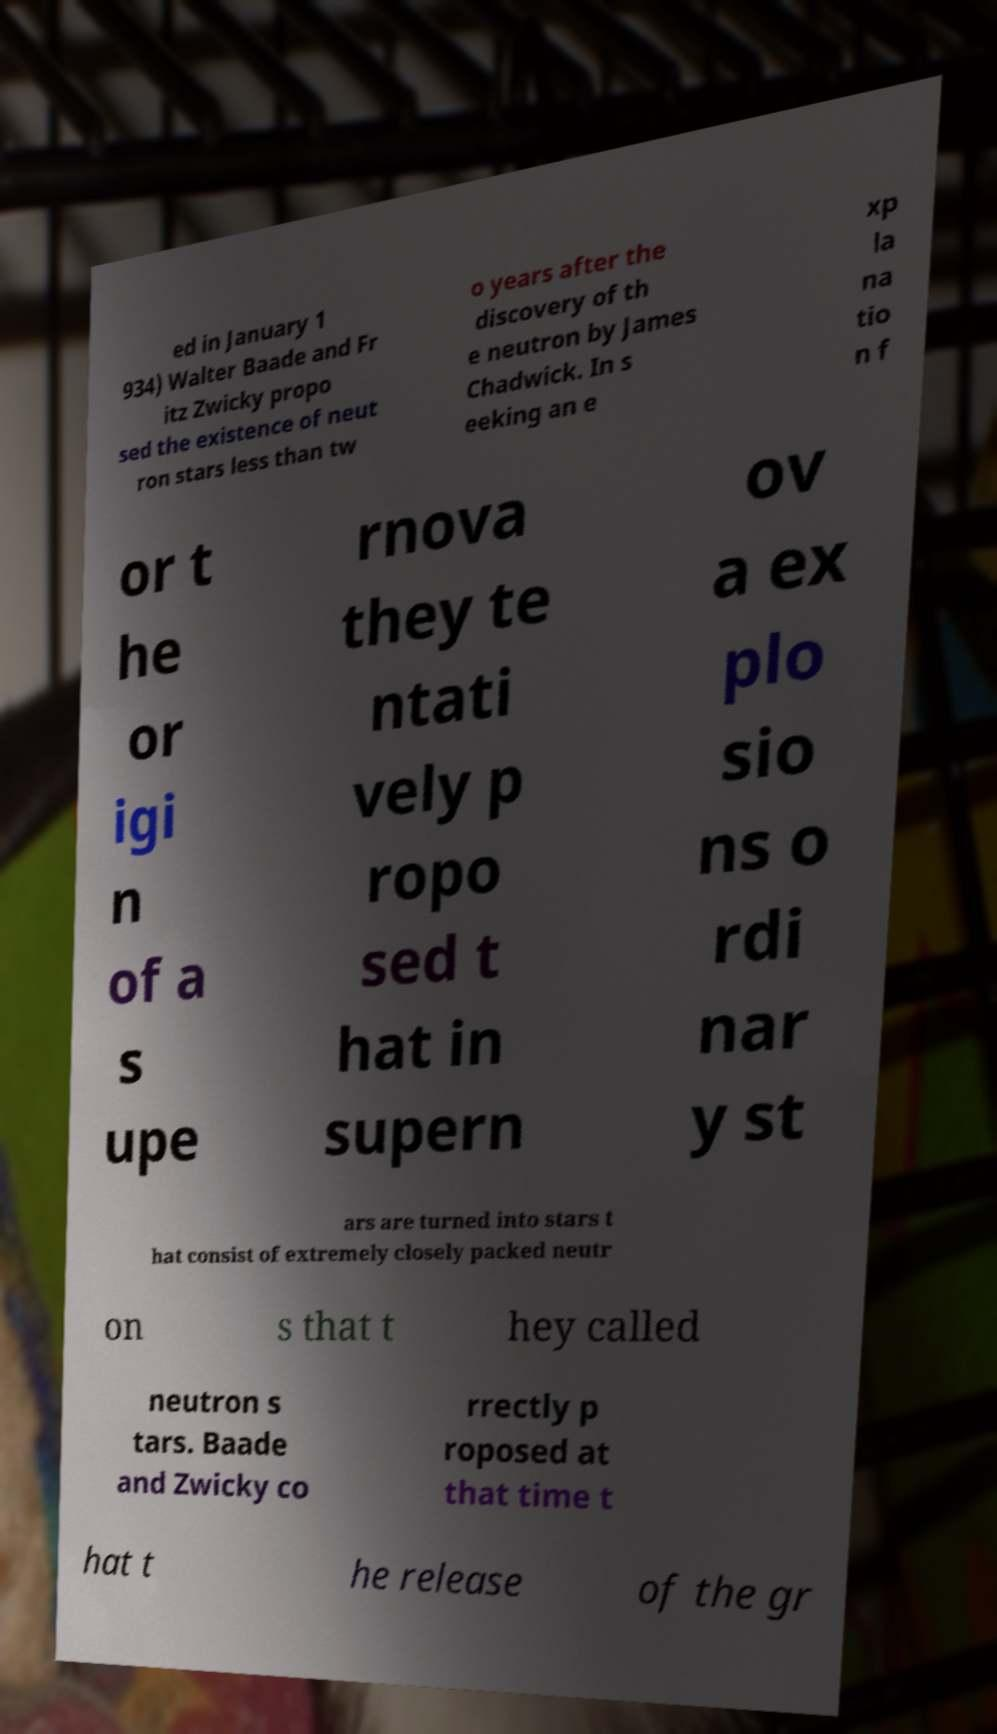There's text embedded in this image that I need extracted. Can you transcribe it verbatim? ed in January 1 934) Walter Baade and Fr itz Zwicky propo sed the existence of neut ron stars less than tw o years after the discovery of th e neutron by James Chadwick. In s eeking an e xp la na tio n f or t he or igi n of a s upe rnova they te ntati vely p ropo sed t hat in supern ov a ex plo sio ns o rdi nar y st ars are turned into stars t hat consist of extremely closely packed neutr on s that t hey called neutron s tars. Baade and Zwicky co rrectly p roposed at that time t hat t he release of the gr 